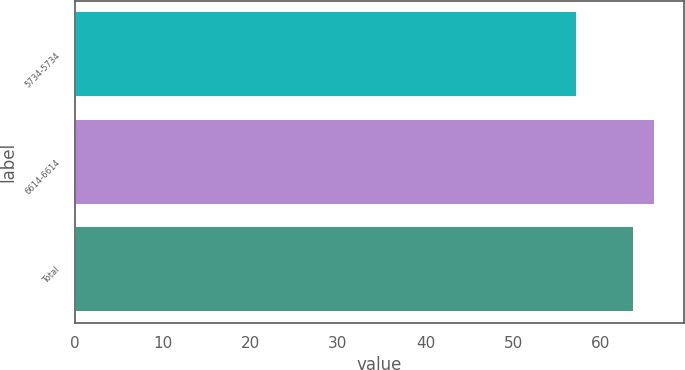<chart> <loc_0><loc_0><loc_500><loc_500><bar_chart><fcel>5734-5734<fcel>6614-6614<fcel>Total<nl><fcel>57.34<fcel>66.14<fcel>63.84<nl></chart> 